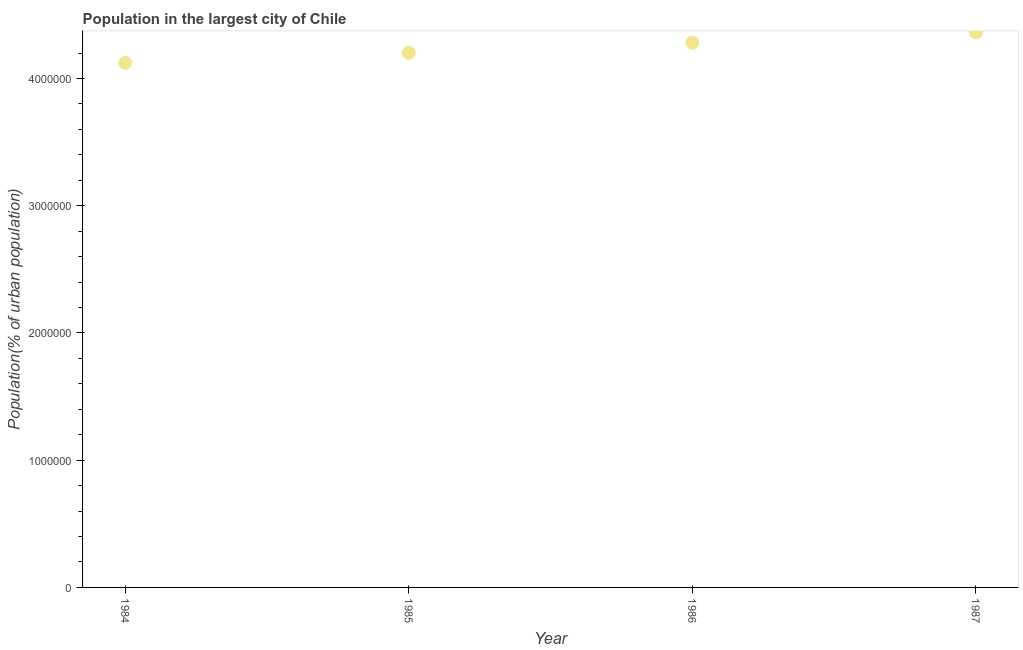What is the population in largest city in 1984?
Provide a short and direct response. 4.12e+06. Across all years, what is the maximum population in largest city?
Provide a succinct answer. 4.36e+06. Across all years, what is the minimum population in largest city?
Offer a very short reply. 4.12e+06. In which year was the population in largest city maximum?
Ensure brevity in your answer.  1987. In which year was the population in largest city minimum?
Make the answer very short. 1984. What is the sum of the population in largest city?
Your response must be concise. 1.70e+07. What is the difference between the population in largest city in 1986 and 1987?
Provide a short and direct response. -8.13e+04. What is the average population in largest city per year?
Offer a terse response. 4.24e+06. What is the median population in largest city?
Offer a terse response. 4.24e+06. In how many years, is the population in largest city greater than 1000000 %?
Your response must be concise. 4. What is the ratio of the population in largest city in 1985 to that in 1987?
Make the answer very short. 0.96. What is the difference between the highest and the second highest population in largest city?
Give a very brief answer. 8.13e+04. What is the difference between the highest and the lowest population in largest city?
Ensure brevity in your answer.  2.39e+05. Does the population in largest city monotonically increase over the years?
Ensure brevity in your answer.  Yes. How many dotlines are there?
Offer a terse response. 1. Does the graph contain any zero values?
Provide a short and direct response. No. Does the graph contain grids?
Keep it short and to the point. No. What is the title of the graph?
Your response must be concise. Population in the largest city of Chile. What is the label or title of the Y-axis?
Keep it short and to the point. Population(% of urban population). What is the Population(% of urban population) in 1984?
Your answer should be compact. 4.12e+06. What is the Population(% of urban population) in 1985?
Ensure brevity in your answer.  4.20e+06. What is the Population(% of urban population) in 1986?
Offer a terse response. 4.28e+06. What is the Population(% of urban population) in 1987?
Keep it short and to the point. 4.36e+06. What is the difference between the Population(% of urban population) in 1984 and 1985?
Your answer should be compact. -7.82e+04. What is the difference between the Population(% of urban population) in 1984 and 1986?
Your answer should be very brief. -1.58e+05. What is the difference between the Population(% of urban population) in 1984 and 1987?
Make the answer very short. -2.39e+05. What is the difference between the Population(% of urban population) in 1985 and 1986?
Ensure brevity in your answer.  -7.98e+04. What is the difference between the Population(% of urban population) in 1985 and 1987?
Offer a terse response. -1.61e+05. What is the difference between the Population(% of urban population) in 1986 and 1987?
Make the answer very short. -8.13e+04. What is the ratio of the Population(% of urban population) in 1984 to that in 1986?
Provide a succinct answer. 0.96. What is the ratio of the Population(% of urban population) in 1984 to that in 1987?
Keep it short and to the point. 0.94. What is the ratio of the Population(% of urban population) in 1985 to that in 1986?
Your answer should be compact. 0.98. What is the ratio of the Population(% of urban population) in 1986 to that in 1987?
Provide a succinct answer. 0.98. 